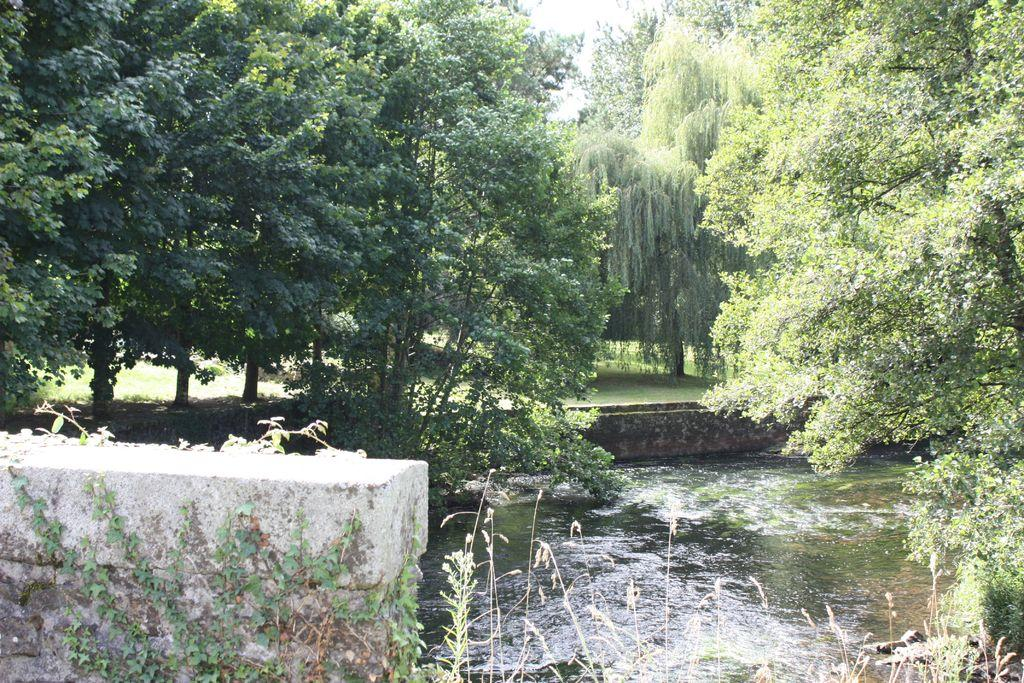What is the primary element visible in the image? There is water in the image. What type of structure can be seen in the image? There is a wall in the image. What type of vegetation is present in the image? There are green trees in the image. What type of oatmeal is being served on the boats in the image? There are no boats or oatmeal present in the image; it only features water, a wall, and green trees. 